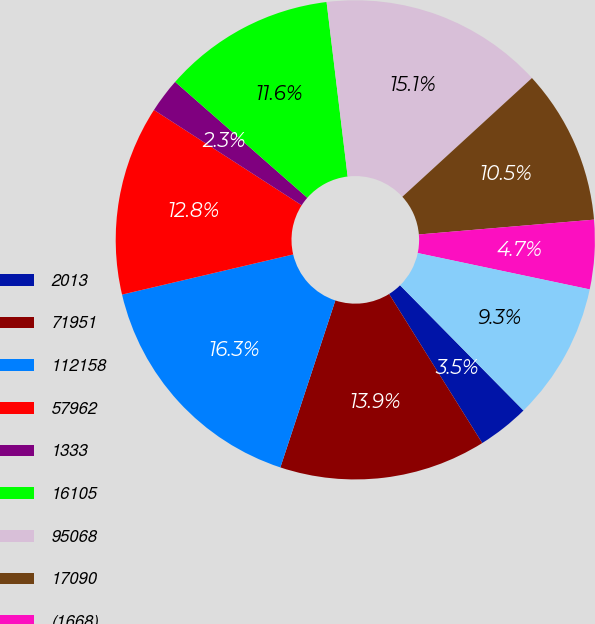Convert chart. <chart><loc_0><loc_0><loc_500><loc_500><pie_chart><fcel>2013<fcel>71951<fcel>112158<fcel>57962<fcel>1333<fcel>16105<fcel>95068<fcel>17090<fcel>(1668)<fcel>15422<nl><fcel>3.5%<fcel>13.95%<fcel>16.27%<fcel>12.79%<fcel>2.34%<fcel>11.63%<fcel>15.11%<fcel>10.46%<fcel>4.66%<fcel>9.3%<nl></chart> 